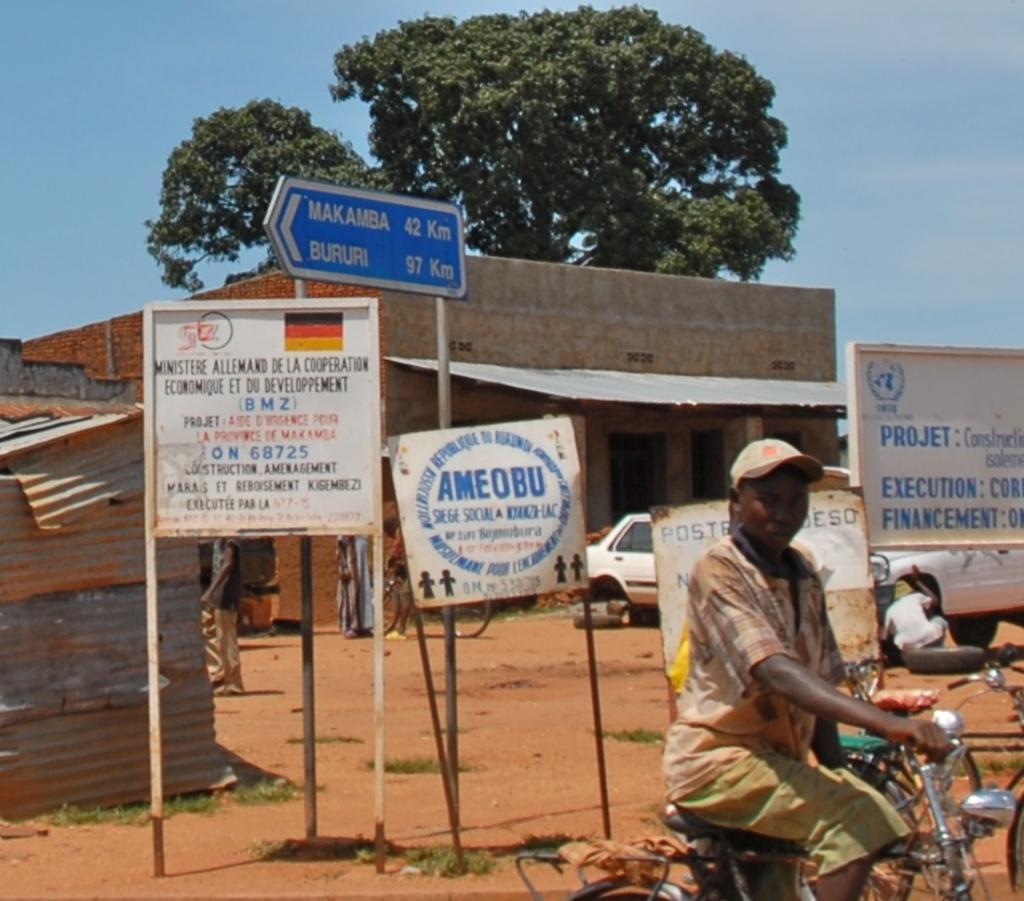Can you describe this image briefly? In this image we can see a person on the bicycle. In the background, we can see cars, people, boards, grass, land, buildings and tree. At the top of the image, we can see the sky. We can see a tyre on the right side of the image. 